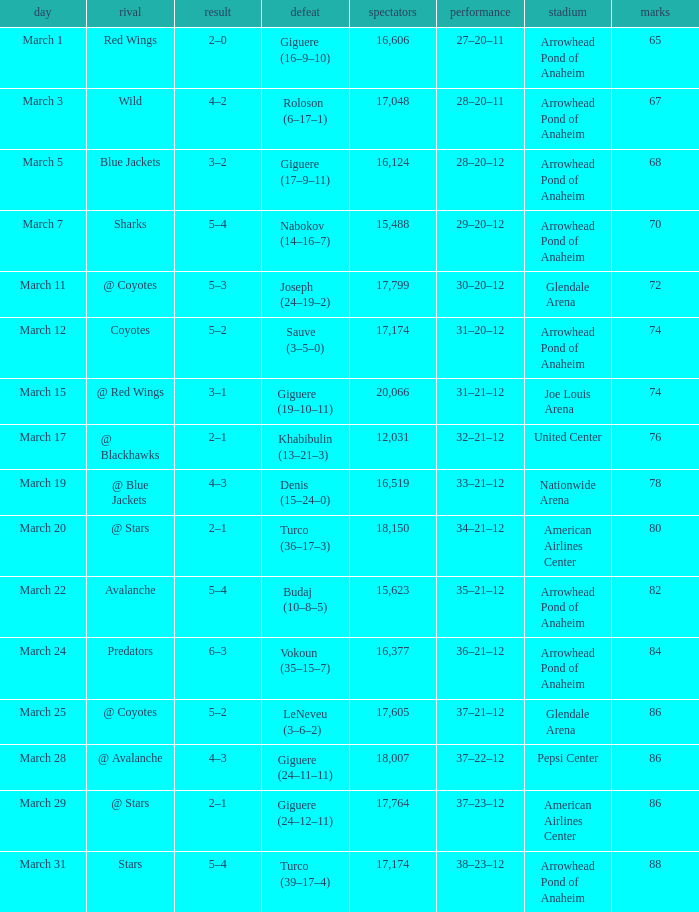What is the Loss of the game at Nationwide Arena with a Score of 4–3? Denis (15–24–0). 